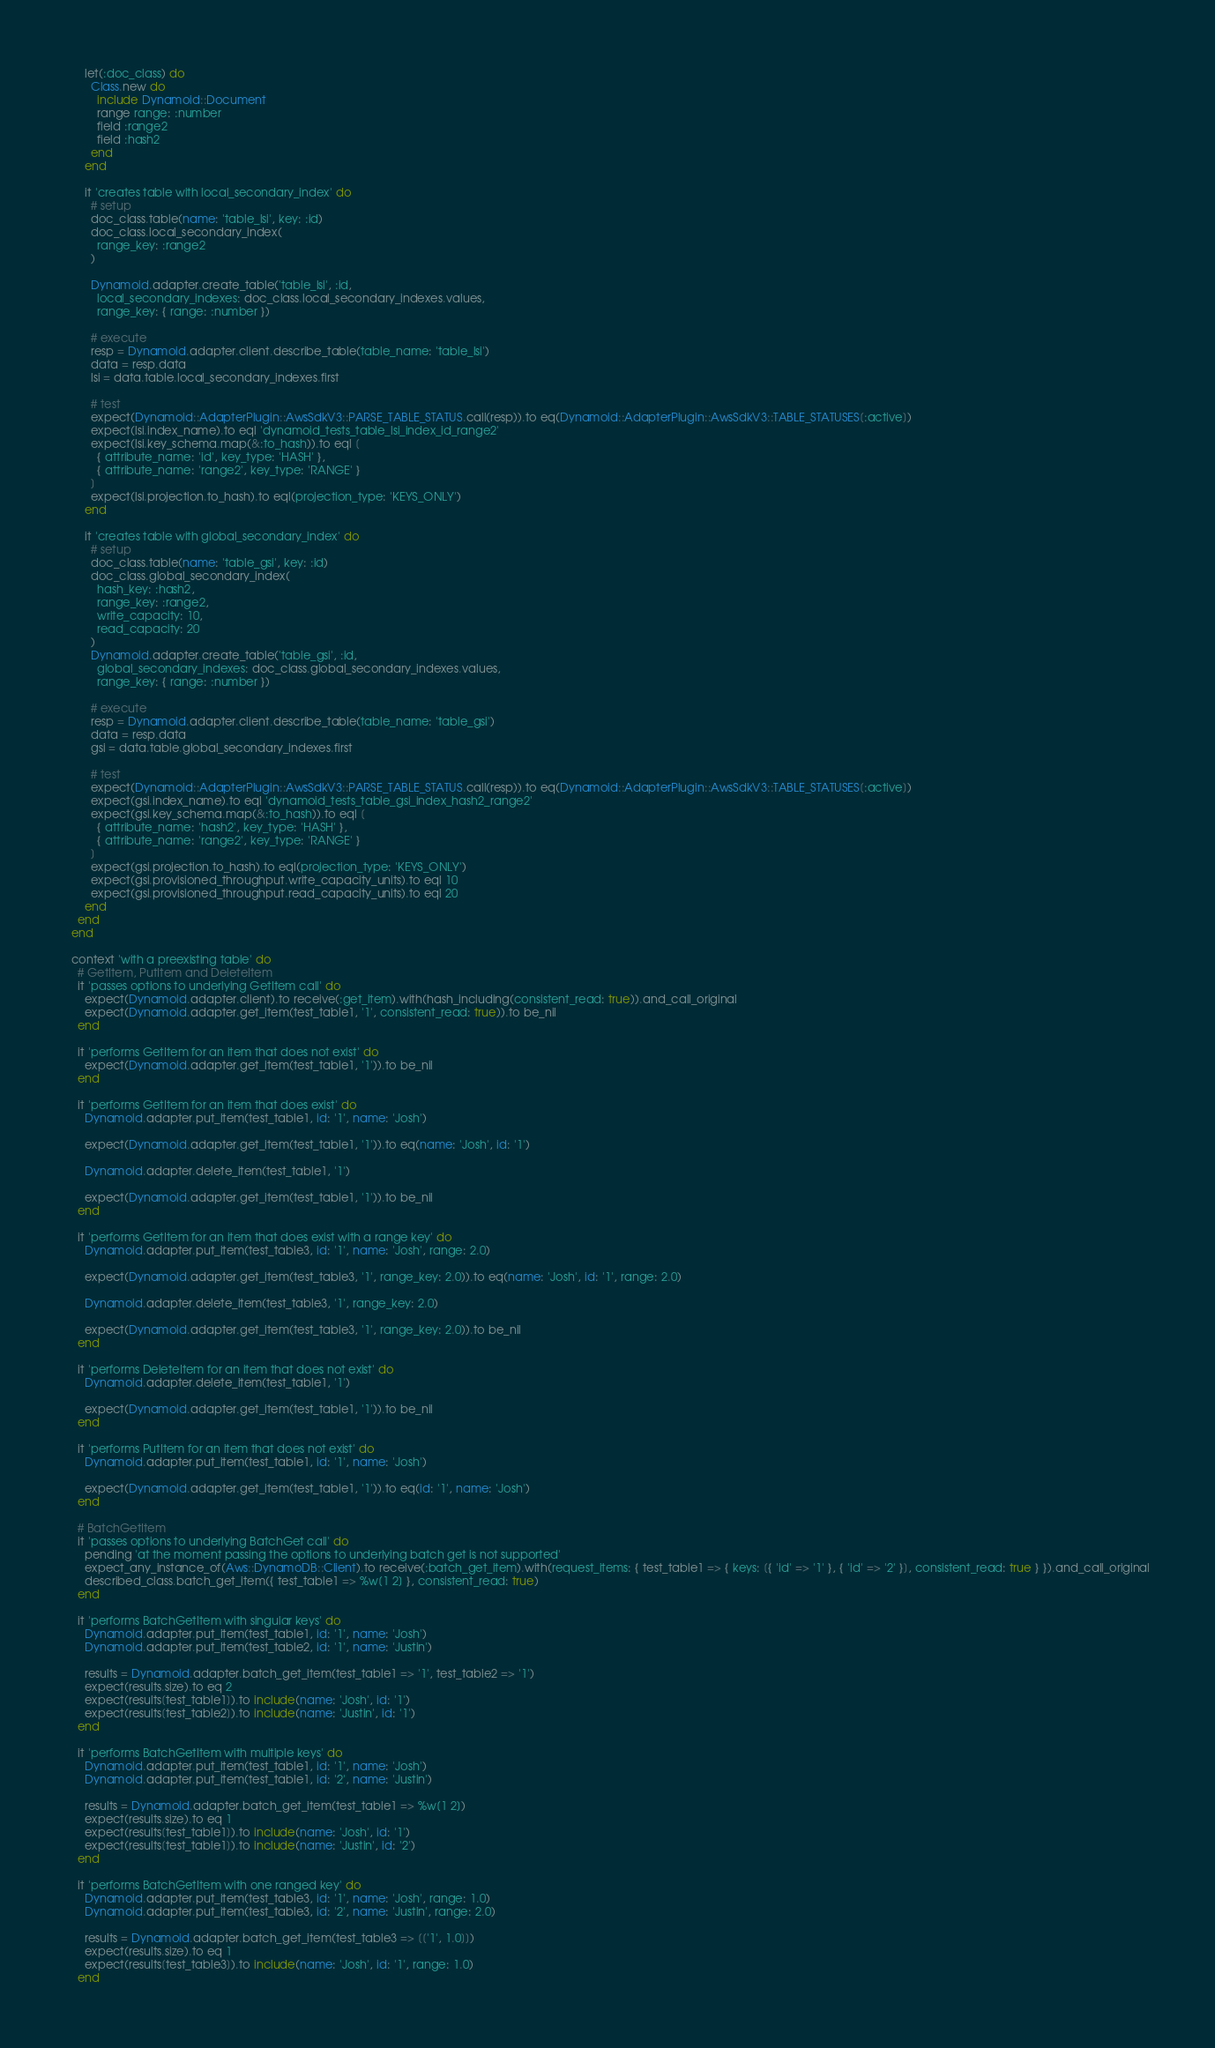Convert code to text. <code><loc_0><loc_0><loc_500><loc_500><_Ruby_>      let(:doc_class) do
        Class.new do
          include Dynamoid::Document
          range range: :number
          field :range2
          field :hash2
        end
      end

      it 'creates table with local_secondary_index' do
        # setup
        doc_class.table(name: 'table_lsi', key: :id)
        doc_class.local_secondary_index(
          range_key: :range2
        )

        Dynamoid.adapter.create_table('table_lsi', :id,
          local_secondary_indexes: doc_class.local_secondary_indexes.values,
          range_key: { range: :number })

        # execute
        resp = Dynamoid.adapter.client.describe_table(table_name: 'table_lsi')
        data = resp.data
        lsi = data.table.local_secondary_indexes.first

        # test
        expect(Dynamoid::AdapterPlugin::AwsSdkV3::PARSE_TABLE_STATUS.call(resp)).to eq(Dynamoid::AdapterPlugin::AwsSdkV3::TABLE_STATUSES[:active])
        expect(lsi.index_name).to eql 'dynamoid_tests_table_lsi_index_id_range2'
        expect(lsi.key_schema.map(&:to_hash)).to eql [
          { attribute_name: 'id', key_type: 'HASH' },
          { attribute_name: 'range2', key_type: 'RANGE' }
        ]
        expect(lsi.projection.to_hash).to eql(projection_type: 'KEYS_ONLY')
      end

      it 'creates table with global_secondary_index' do
        # setup
        doc_class.table(name: 'table_gsi', key: :id)
        doc_class.global_secondary_index(
          hash_key: :hash2,
          range_key: :range2,
          write_capacity: 10,
          read_capacity: 20
        )
        Dynamoid.adapter.create_table('table_gsi', :id,
          global_secondary_indexes: doc_class.global_secondary_indexes.values,
          range_key: { range: :number })

        # execute
        resp = Dynamoid.adapter.client.describe_table(table_name: 'table_gsi')
        data = resp.data
        gsi = data.table.global_secondary_indexes.first

        # test
        expect(Dynamoid::AdapterPlugin::AwsSdkV3::PARSE_TABLE_STATUS.call(resp)).to eq(Dynamoid::AdapterPlugin::AwsSdkV3::TABLE_STATUSES[:active])
        expect(gsi.index_name).to eql 'dynamoid_tests_table_gsi_index_hash2_range2'
        expect(gsi.key_schema.map(&:to_hash)).to eql [
          { attribute_name: 'hash2', key_type: 'HASH' },
          { attribute_name: 'range2', key_type: 'RANGE' }
        ]
        expect(gsi.projection.to_hash).to eql(projection_type: 'KEYS_ONLY')
        expect(gsi.provisioned_throughput.write_capacity_units).to eql 10
        expect(gsi.provisioned_throughput.read_capacity_units).to eql 20
      end
    end
  end

  context 'with a preexisting table' do
    # GetItem, PutItem and DeleteItem
    it 'passes options to underlying GetItem call' do
      expect(Dynamoid.adapter.client).to receive(:get_item).with(hash_including(consistent_read: true)).and_call_original
      expect(Dynamoid.adapter.get_item(test_table1, '1', consistent_read: true)).to be_nil
    end

    it 'performs GetItem for an item that does not exist' do
      expect(Dynamoid.adapter.get_item(test_table1, '1')).to be_nil
    end

    it 'performs GetItem for an item that does exist' do
      Dynamoid.adapter.put_item(test_table1, id: '1', name: 'Josh')

      expect(Dynamoid.adapter.get_item(test_table1, '1')).to eq(name: 'Josh', id: '1')

      Dynamoid.adapter.delete_item(test_table1, '1')

      expect(Dynamoid.adapter.get_item(test_table1, '1')).to be_nil
    end

    it 'performs GetItem for an item that does exist with a range key' do
      Dynamoid.adapter.put_item(test_table3, id: '1', name: 'Josh', range: 2.0)

      expect(Dynamoid.adapter.get_item(test_table3, '1', range_key: 2.0)).to eq(name: 'Josh', id: '1', range: 2.0)

      Dynamoid.adapter.delete_item(test_table3, '1', range_key: 2.0)

      expect(Dynamoid.adapter.get_item(test_table3, '1', range_key: 2.0)).to be_nil
    end

    it 'performs DeleteItem for an item that does not exist' do
      Dynamoid.adapter.delete_item(test_table1, '1')

      expect(Dynamoid.adapter.get_item(test_table1, '1')).to be_nil
    end

    it 'performs PutItem for an item that does not exist' do
      Dynamoid.adapter.put_item(test_table1, id: '1', name: 'Josh')

      expect(Dynamoid.adapter.get_item(test_table1, '1')).to eq(id: '1', name: 'Josh')
    end

    # BatchGetItem
    it 'passes options to underlying BatchGet call' do
      pending 'at the moment passing the options to underlying batch get is not supported'
      expect_any_instance_of(Aws::DynamoDB::Client).to receive(:batch_get_item).with(request_items: { test_table1 => { keys: [{ 'id' => '1' }, { 'id' => '2' }], consistent_read: true } }).and_call_original
      described_class.batch_get_item({ test_table1 => %w[1 2] }, consistent_read: true)
    end

    it 'performs BatchGetItem with singular keys' do
      Dynamoid.adapter.put_item(test_table1, id: '1', name: 'Josh')
      Dynamoid.adapter.put_item(test_table2, id: '1', name: 'Justin')

      results = Dynamoid.adapter.batch_get_item(test_table1 => '1', test_table2 => '1')
      expect(results.size).to eq 2
      expect(results[test_table1]).to include(name: 'Josh', id: '1')
      expect(results[test_table2]).to include(name: 'Justin', id: '1')
    end

    it 'performs BatchGetItem with multiple keys' do
      Dynamoid.adapter.put_item(test_table1, id: '1', name: 'Josh')
      Dynamoid.adapter.put_item(test_table1, id: '2', name: 'Justin')

      results = Dynamoid.adapter.batch_get_item(test_table1 => %w[1 2])
      expect(results.size).to eq 1
      expect(results[test_table1]).to include(name: 'Josh', id: '1')
      expect(results[test_table1]).to include(name: 'Justin', id: '2')
    end

    it 'performs BatchGetItem with one ranged key' do
      Dynamoid.adapter.put_item(test_table3, id: '1', name: 'Josh', range: 1.0)
      Dynamoid.adapter.put_item(test_table3, id: '2', name: 'Justin', range: 2.0)

      results = Dynamoid.adapter.batch_get_item(test_table3 => [['1', 1.0]])
      expect(results.size).to eq 1
      expect(results[test_table3]).to include(name: 'Josh', id: '1', range: 1.0)
    end
</code> 